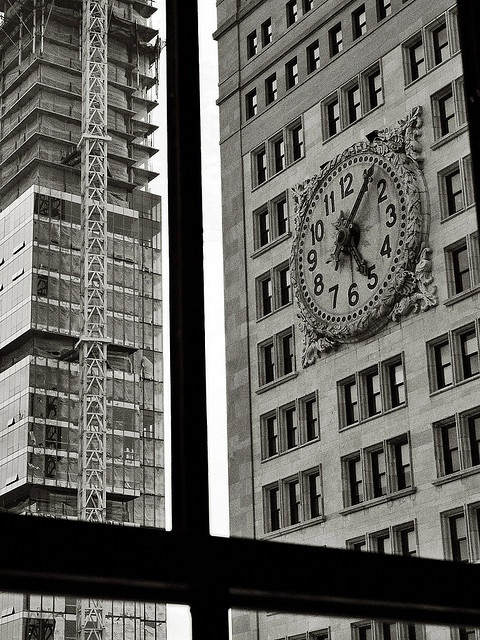Describe the objects in this image and their specific colors. I can see a clock in black, darkgray, and gray tones in this image. 